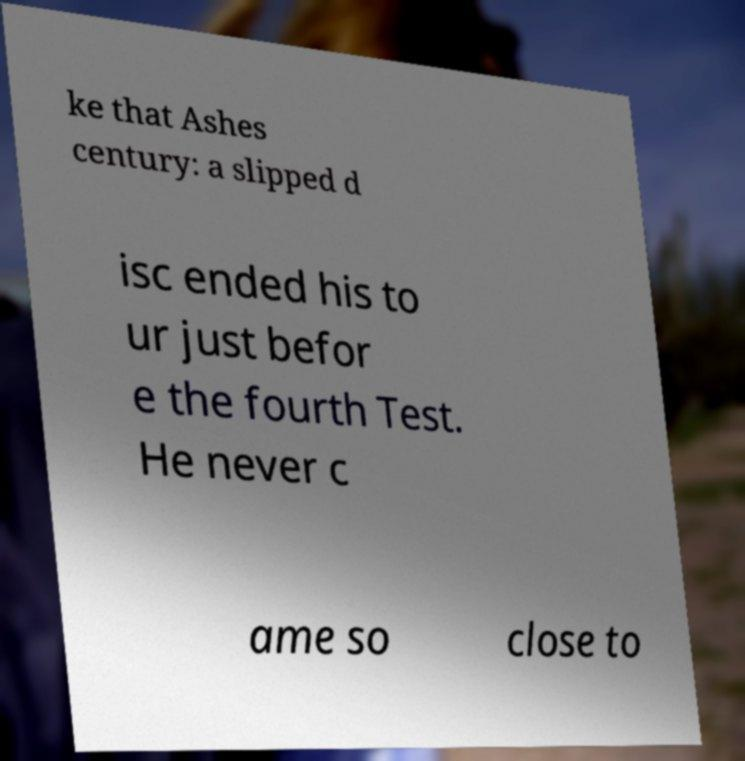Could you assist in decoding the text presented in this image and type it out clearly? ke that Ashes century: a slipped d isc ended his to ur just befor e the fourth Test. He never c ame so close to 